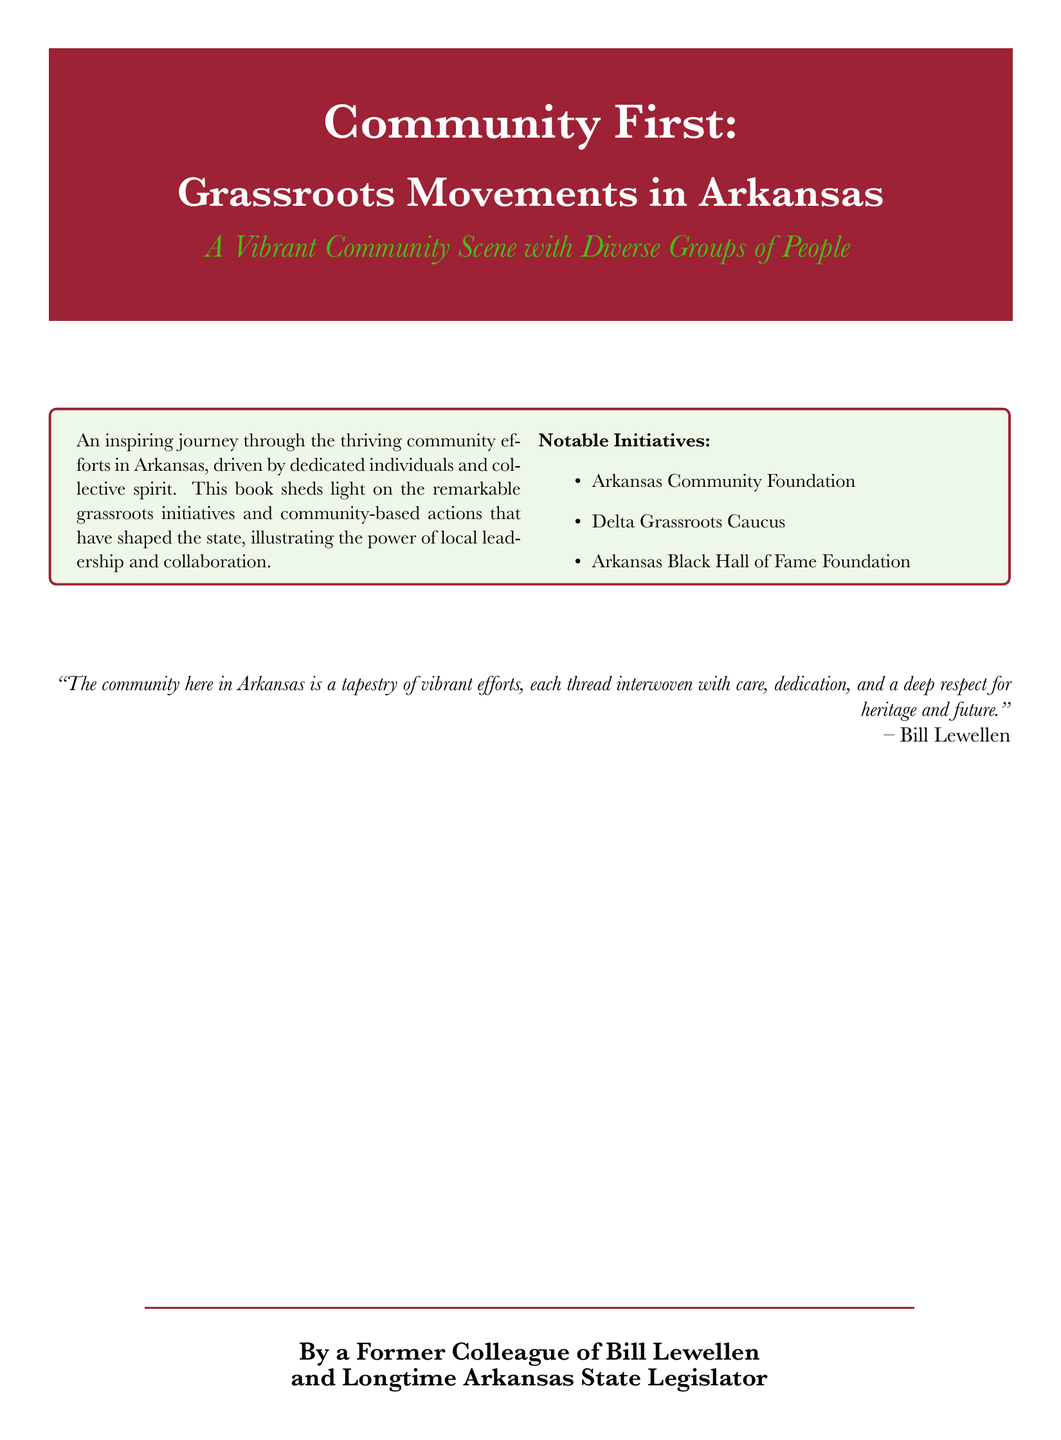what is the title of the book? The title of the book is prominently displayed in a large font at the top of the cover.
Answer: Community First: Grassroots Movements in Arkansas who is the author of the book? The author is referred to at the bottom of the cover as "By a Former Colleague of Bill Lewellen and Longtime Arkansas State Legislator".
Answer: A Former Colleague of Bill Lewellen what color is associated with Arkansas on the cover? Arkansas is represented by a specific color defined in the document that appears in the title background.
Answer: Arkansas Red which notable initiative is mentioned first in the list? The notable initiatives are outlined in a section of the cover, and the first mentioned is clearly stated.
Answer: Arkansas Community Foundation what is the predominant theme of the book? The main theme is summarized in the subtitle, indicating the focus of the book.
Answer: Grassroots Movements who is quoted on the cover? A quote appears on the cover and is attributed to a specific individual.
Answer: Bill Lewellen what is the background color of the tcolorbox? The background color is specified for the tcolorbox within the document.
Answer: Grass Green how many notable initiatives are listed? The number of notable initiatives can be counted from the bulleted list provided.
Answer: Three 